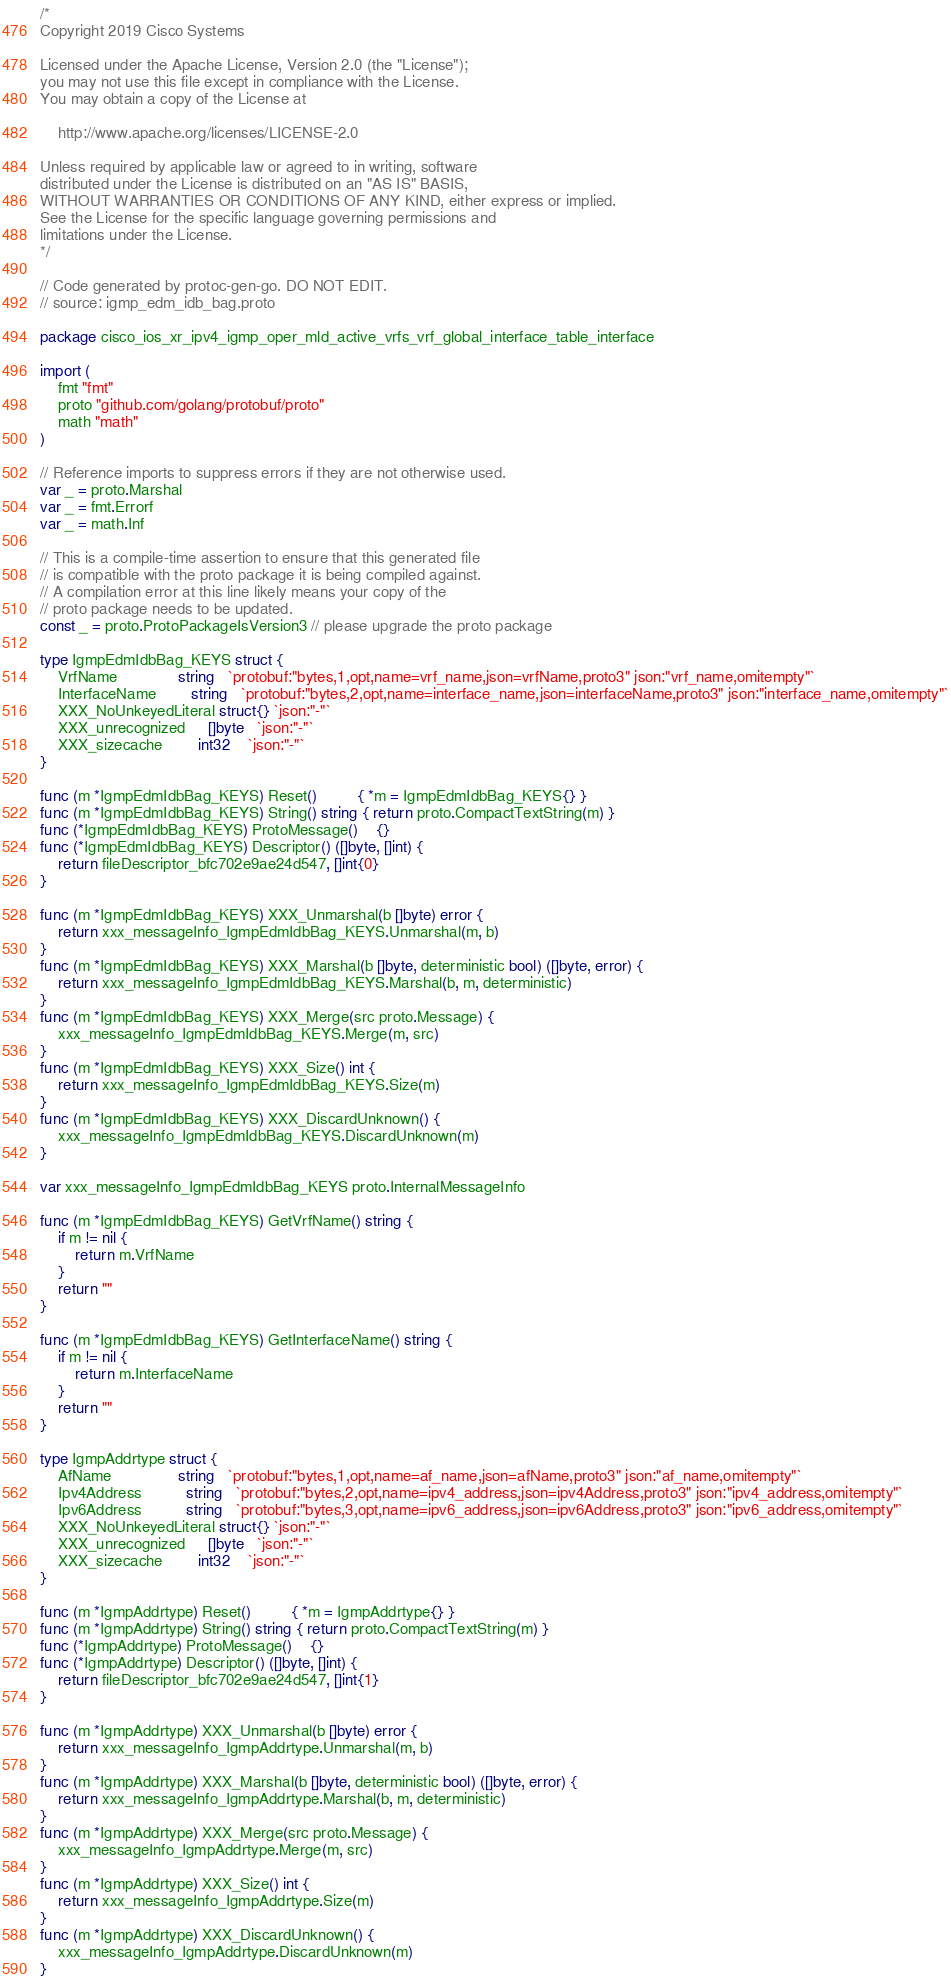Convert code to text. <code><loc_0><loc_0><loc_500><loc_500><_Go_>/*
Copyright 2019 Cisco Systems

Licensed under the Apache License, Version 2.0 (the "License");
you may not use this file except in compliance with the License.
You may obtain a copy of the License at

    http://www.apache.org/licenses/LICENSE-2.0

Unless required by applicable law or agreed to in writing, software
distributed under the License is distributed on an "AS IS" BASIS,
WITHOUT WARRANTIES OR CONDITIONS OF ANY KIND, either express or implied.
See the License for the specific language governing permissions and
limitations under the License.
*/

// Code generated by protoc-gen-go. DO NOT EDIT.
// source: igmp_edm_idb_bag.proto

package cisco_ios_xr_ipv4_igmp_oper_mld_active_vrfs_vrf_global_interface_table_interface

import (
	fmt "fmt"
	proto "github.com/golang/protobuf/proto"
	math "math"
)

// Reference imports to suppress errors if they are not otherwise used.
var _ = proto.Marshal
var _ = fmt.Errorf
var _ = math.Inf

// This is a compile-time assertion to ensure that this generated file
// is compatible with the proto package it is being compiled against.
// A compilation error at this line likely means your copy of the
// proto package needs to be updated.
const _ = proto.ProtoPackageIsVersion3 // please upgrade the proto package

type IgmpEdmIdbBag_KEYS struct {
	VrfName              string   `protobuf:"bytes,1,opt,name=vrf_name,json=vrfName,proto3" json:"vrf_name,omitempty"`
	InterfaceName        string   `protobuf:"bytes,2,opt,name=interface_name,json=interfaceName,proto3" json:"interface_name,omitempty"`
	XXX_NoUnkeyedLiteral struct{} `json:"-"`
	XXX_unrecognized     []byte   `json:"-"`
	XXX_sizecache        int32    `json:"-"`
}

func (m *IgmpEdmIdbBag_KEYS) Reset()         { *m = IgmpEdmIdbBag_KEYS{} }
func (m *IgmpEdmIdbBag_KEYS) String() string { return proto.CompactTextString(m) }
func (*IgmpEdmIdbBag_KEYS) ProtoMessage()    {}
func (*IgmpEdmIdbBag_KEYS) Descriptor() ([]byte, []int) {
	return fileDescriptor_bfc702e9ae24d547, []int{0}
}

func (m *IgmpEdmIdbBag_KEYS) XXX_Unmarshal(b []byte) error {
	return xxx_messageInfo_IgmpEdmIdbBag_KEYS.Unmarshal(m, b)
}
func (m *IgmpEdmIdbBag_KEYS) XXX_Marshal(b []byte, deterministic bool) ([]byte, error) {
	return xxx_messageInfo_IgmpEdmIdbBag_KEYS.Marshal(b, m, deterministic)
}
func (m *IgmpEdmIdbBag_KEYS) XXX_Merge(src proto.Message) {
	xxx_messageInfo_IgmpEdmIdbBag_KEYS.Merge(m, src)
}
func (m *IgmpEdmIdbBag_KEYS) XXX_Size() int {
	return xxx_messageInfo_IgmpEdmIdbBag_KEYS.Size(m)
}
func (m *IgmpEdmIdbBag_KEYS) XXX_DiscardUnknown() {
	xxx_messageInfo_IgmpEdmIdbBag_KEYS.DiscardUnknown(m)
}

var xxx_messageInfo_IgmpEdmIdbBag_KEYS proto.InternalMessageInfo

func (m *IgmpEdmIdbBag_KEYS) GetVrfName() string {
	if m != nil {
		return m.VrfName
	}
	return ""
}

func (m *IgmpEdmIdbBag_KEYS) GetInterfaceName() string {
	if m != nil {
		return m.InterfaceName
	}
	return ""
}

type IgmpAddrtype struct {
	AfName               string   `protobuf:"bytes,1,opt,name=af_name,json=afName,proto3" json:"af_name,omitempty"`
	Ipv4Address          string   `protobuf:"bytes,2,opt,name=ipv4_address,json=ipv4Address,proto3" json:"ipv4_address,omitempty"`
	Ipv6Address          string   `protobuf:"bytes,3,opt,name=ipv6_address,json=ipv6Address,proto3" json:"ipv6_address,omitempty"`
	XXX_NoUnkeyedLiteral struct{} `json:"-"`
	XXX_unrecognized     []byte   `json:"-"`
	XXX_sizecache        int32    `json:"-"`
}

func (m *IgmpAddrtype) Reset()         { *m = IgmpAddrtype{} }
func (m *IgmpAddrtype) String() string { return proto.CompactTextString(m) }
func (*IgmpAddrtype) ProtoMessage()    {}
func (*IgmpAddrtype) Descriptor() ([]byte, []int) {
	return fileDescriptor_bfc702e9ae24d547, []int{1}
}

func (m *IgmpAddrtype) XXX_Unmarshal(b []byte) error {
	return xxx_messageInfo_IgmpAddrtype.Unmarshal(m, b)
}
func (m *IgmpAddrtype) XXX_Marshal(b []byte, deterministic bool) ([]byte, error) {
	return xxx_messageInfo_IgmpAddrtype.Marshal(b, m, deterministic)
}
func (m *IgmpAddrtype) XXX_Merge(src proto.Message) {
	xxx_messageInfo_IgmpAddrtype.Merge(m, src)
}
func (m *IgmpAddrtype) XXX_Size() int {
	return xxx_messageInfo_IgmpAddrtype.Size(m)
}
func (m *IgmpAddrtype) XXX_DiscardUnknown() {
	xxx_messageInfo_IgmpAddrtype.DiscardUnknown(m)
}
</code> 